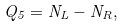<formula> <loc_0><loc_0><loc_500><loc_500>Q _ { 5 } = N _ { L } - N _ { R } ,</formula> 